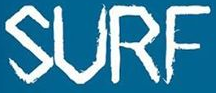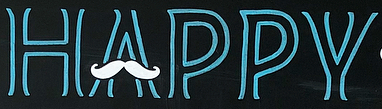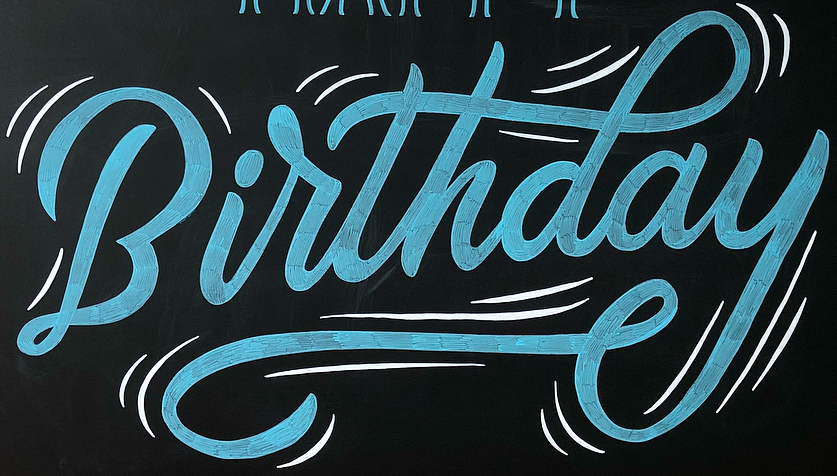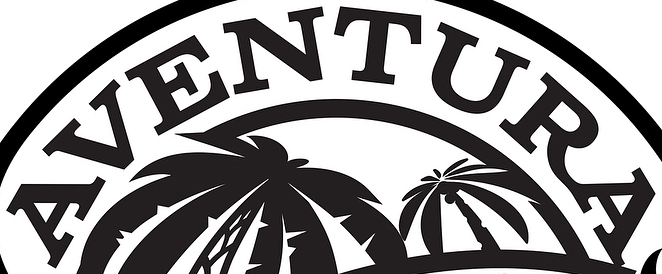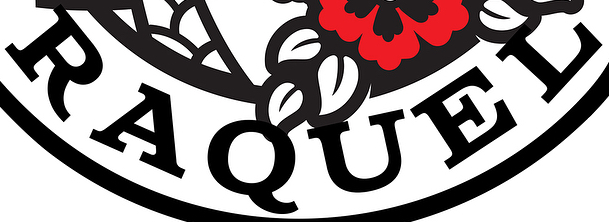Transcribe the words shown in these images in order, separated by a semicolon. SURF; HAPPY; Birthday; AVENTURA; RAQUEL 